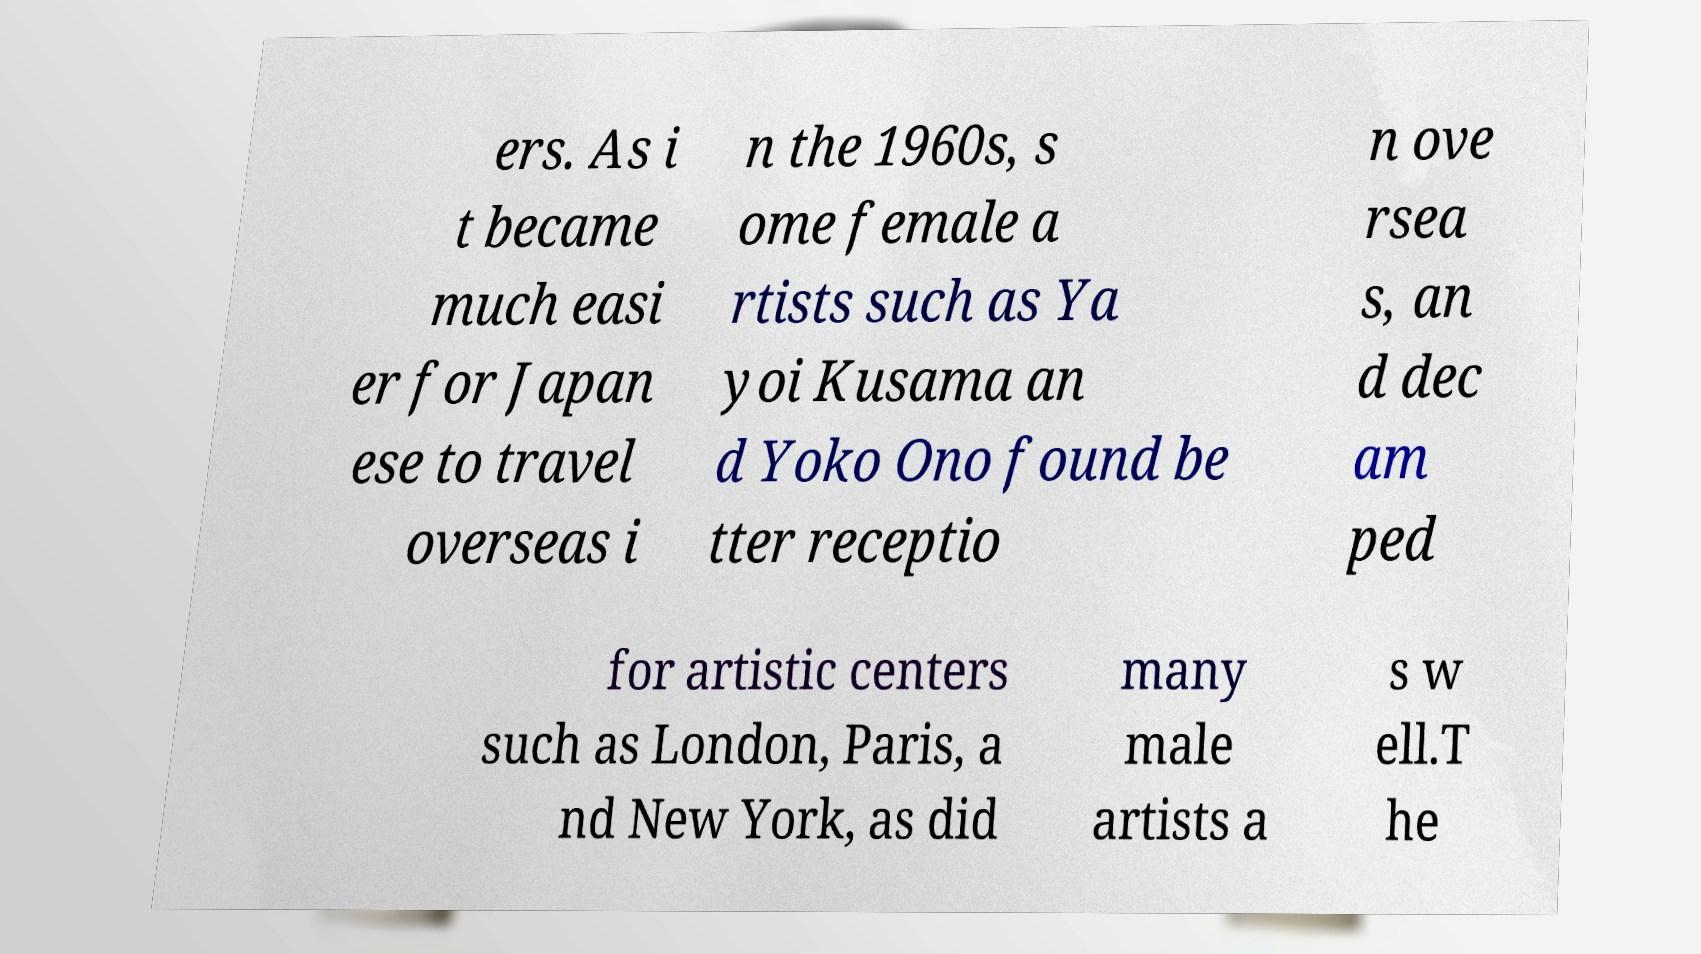Can you accurately transcribe the text from the provided image for me? ers. As i t became much easi er for Japan ese to travel overseas i n the 1960s, s ome female a rtists such as Ya yoi Kusama an d Yoko Ono found be tter receptio n ove rsea s, an d dec am ped for artistic centers such as London, Paris, a nd New York, as did many male artists a s w ell.T he 